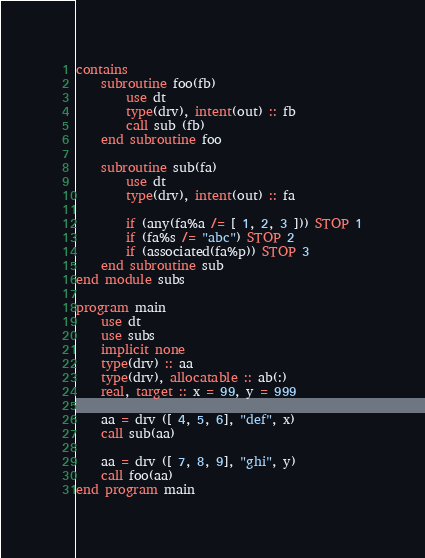Convert code to text. <code><loc_0><loc_0><loc_500><loc_500><_FORTRAN_>contains
    subroutine foo(fb)
        use dt
        type(drv), intent(out) :: fb
        call sub (fb)
    end subroutine foo

    subroutine sub(fa)
        use dt
        type(drv), intent(out) :: fa

        if (any(fa%a /= [ 1, 2, 3 ])) STOP 1
        if (fa%s /= "abc") STOP 2
        if (associated(fa%p)) STOP 3
    end subroutine sub
end module subs

program main
    use dt
    use subs
    implicit none
    type(drv) :: aa
    type(drv), allocatable :: ab(:)
    real, target :: x = 99, y = 999

    aa = drv ([ 4, 5, 6], "def", x)
    call sub(aa)

    aa = drv ([ 7, 8, 9], "ghi", y)
    call foo(aa)
end program main

</code> 